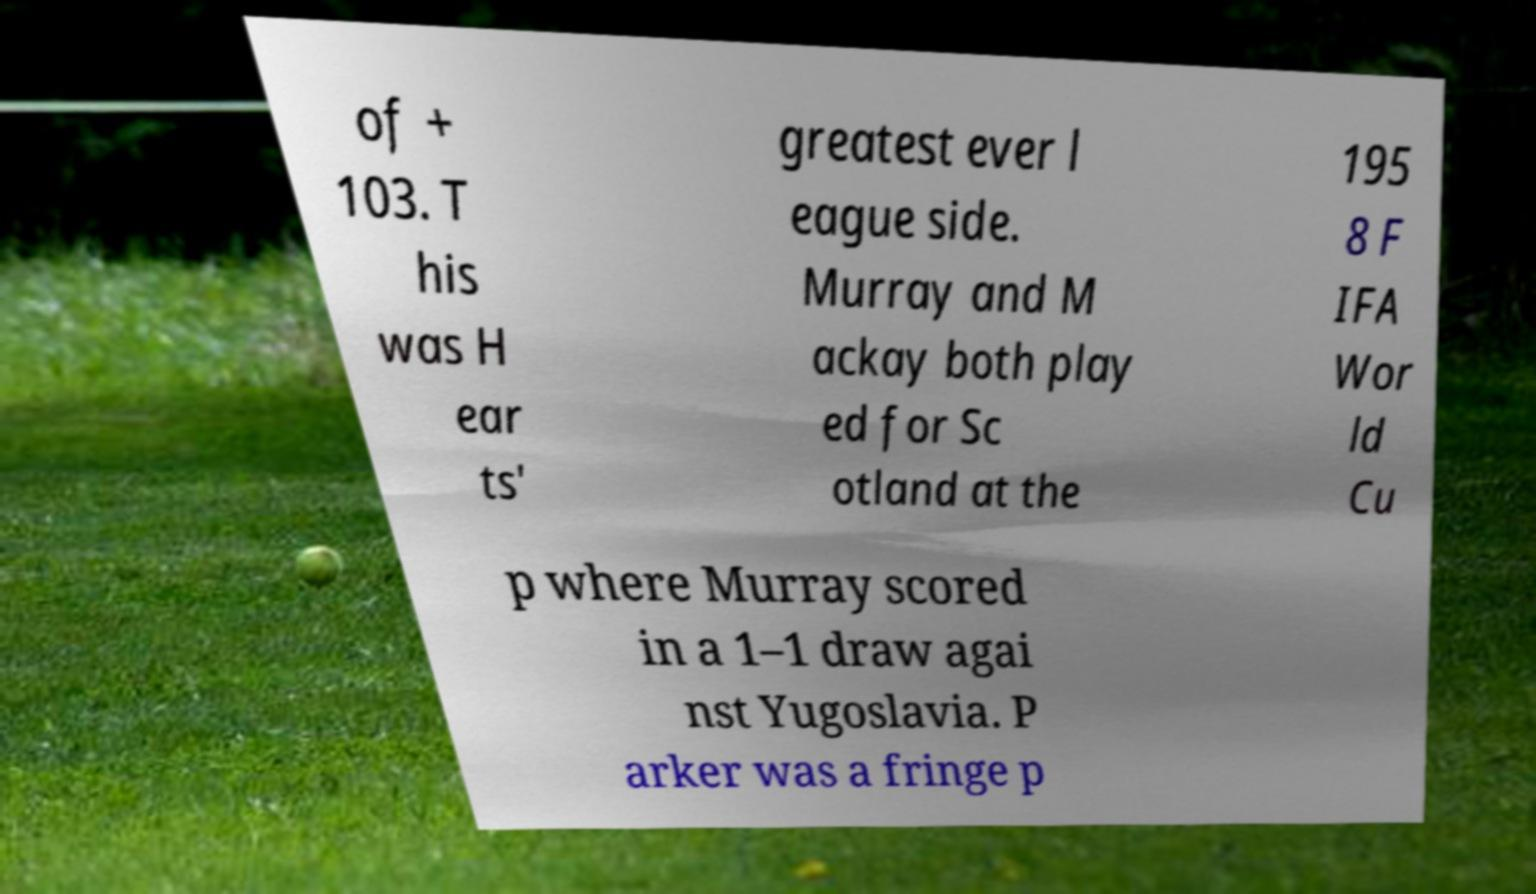Could you assist in decoding the text presented in this image and type it out clearly? of + 103. T his was H ear ts' greatest ever l eague side. Murray and M ackay both play ed for Sc otland at the 195 8 F IFA Wor ld Cu p where Murray scored in a 1–1 draw agai nst Yugoslavia. P arker was a fringe p 